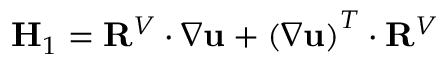<formula> <loc_0><loc_0><loc_500><loc_500>H _ { 1 } = R ^ { V } \cdot \nabla u + \left ( \nabla u \right ) ^ { T } \cdot R ^ { V }</formula> 